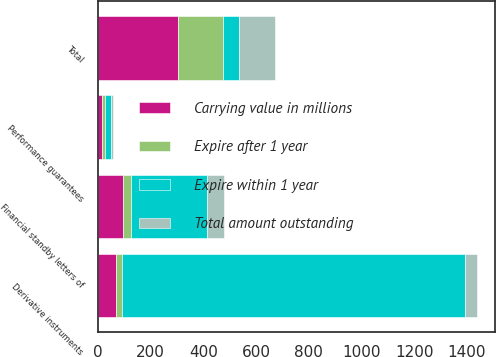Convert chart. <chart><loc_0><loc_0><loc_500><loc_500><stacked_bar_chart><ecel><fcel>Financial standby letters of<fcel>Performance guarantees<fcel>Derivative instruments<fcel>Total<nl><fcel>Expire after 1 year<fcel>31.6<fcel>9.4<fcel>22.5<fcel>167.8<nl><fcel>Total amount outstanding<fcel>62.6<fcel>6.9<fcel>45.4<fcel>137.1<nl><fcel>Carrying value in millions<fcel>94.2<fcel>16.3<fcel>67.9<fcel>304.9<nl><fcel>Expire within 1 year<fcel>289<fcel>23.6<fcel>1301.5<fcel>62.6<nl></chart> 